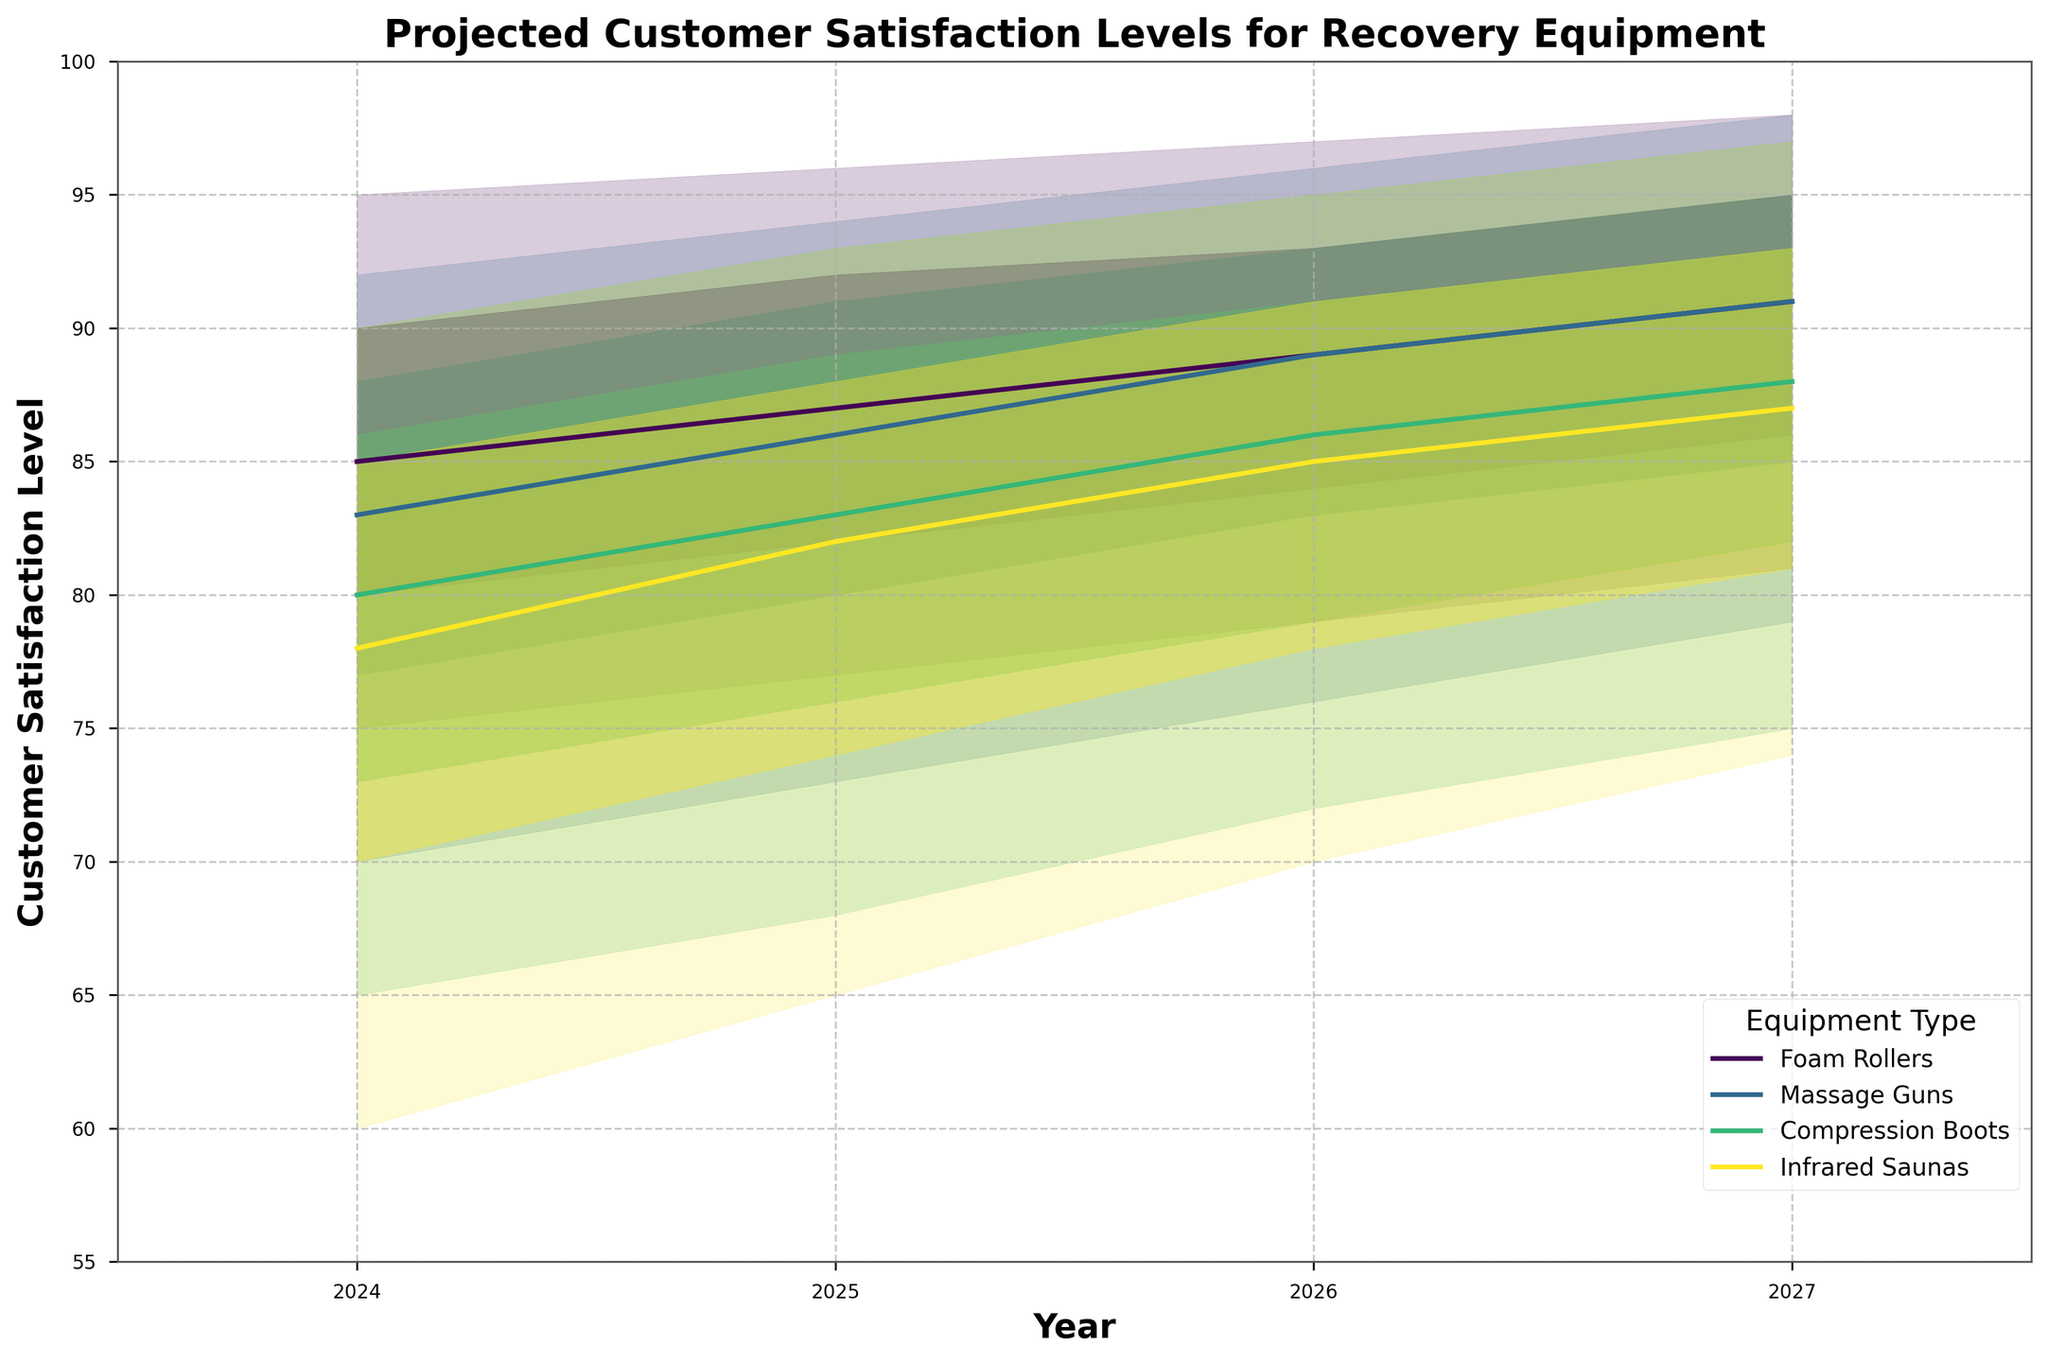How many types of recovery equipment are projected in the figure? There are four unique equipment types: Foam Rollers, Massage Guns, Compression Boots, and Infrared Saunas, as identified by the distinct colors and labels.
Answer: Four What years are covered in the projection? The x-axis shows the projections from the years 2024 to 2027.
Answer: 2024 to 2027 Which recovery equipment has the highest projected satisfaction level in 2027? The highest projected satisfaction level can be seen in Foam Rollers and Massage Guns, with mid-values at about 95.
Answer: Foam Rollers and Massage Guns How does the median satisfaction level of Foam Rollers change from 2024 to 2027? The mid-values for Foam Rollers increase from 85 in 2024 to 91 in 2027.
Answer: Increase from 85 to 91 Which equipment shows the greatest increase in low satisfaction levels from 2024 to 2027? Compression Boots show the greatest increase in low satisfaction levels from 65 in 2024 to 75 in 2027.
Answer: Compression Boots Compare the range of projected customer satisfaction levels (High-Low) between Massage Guns and Infrared Saunas in 2026. For Massage Guns in 2026, the range is 96-76 = 20. For Infrared Saunas in 2026, the range is 95-70 = 25.
Answer: Infrared Saunas have a larger range What is the average mid satisfaction level of Compression Boots over the years? The mid satisfaction levels of Compression Boots are (80+83+86+88). The average is (80+83+86+88)/4 = 84.25.
Answer: 84.25 Which equipment shows the most consistent satisfaction levels over time? Foam Rollers have the smallest range in satisfaction levels across years compared to other equipment, as seen by the similar width of the shaded area.
Answer: Foam Rollers What is the trend in satisfaction levels for Infrared Saunas from 2024 to 2027? The mid satisfaction levels for Infrared Saunas increase from 78 in 2024 to 93 in 2027, indicating an upward trend.
Answer: Increasing Do Compression Boots ever overtake Massage Guns in average satisfaction levels? By comparing mid-values, Compression Boots never surpass Massage Guns in average satisfaction over the years.
Answer: No 